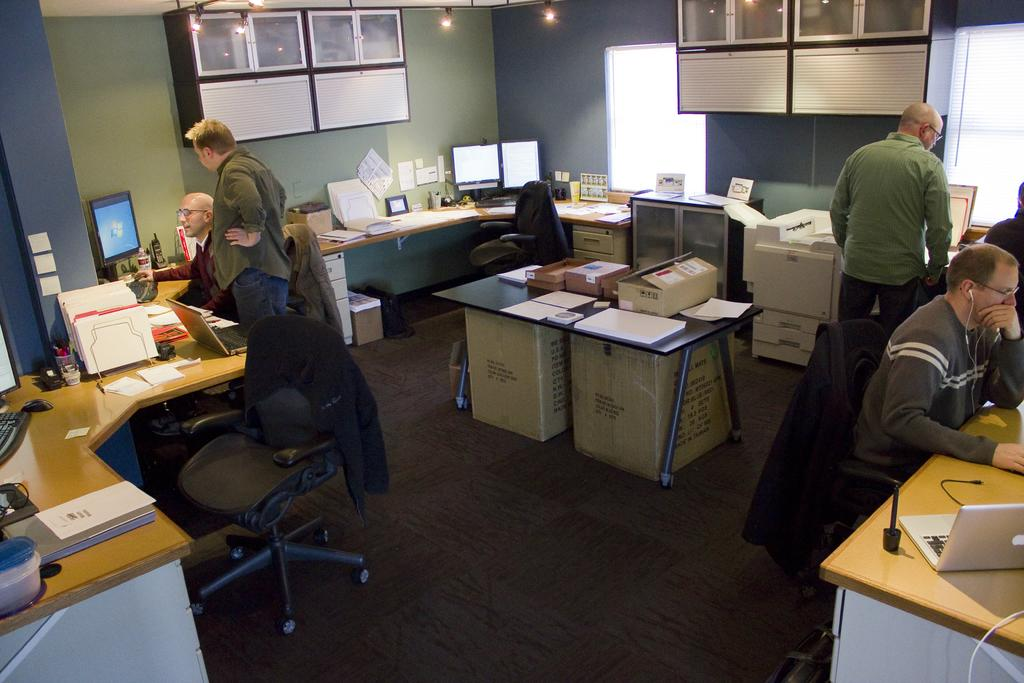What are the people in the image doing? The people in the image are either seated on chairs or standing. What objects can be seen on the table in the image? There are computers, laptops, and papers on the table in the image. What else is present in the image besides people and objects on the table? There are boxes in the image. What color is the chalk used by the person writing on the page in the image? There is no person writing on a page or using chalk in the image. What type of room is depicted in the image? The provided facts do not give any information about the type of room in the image. 